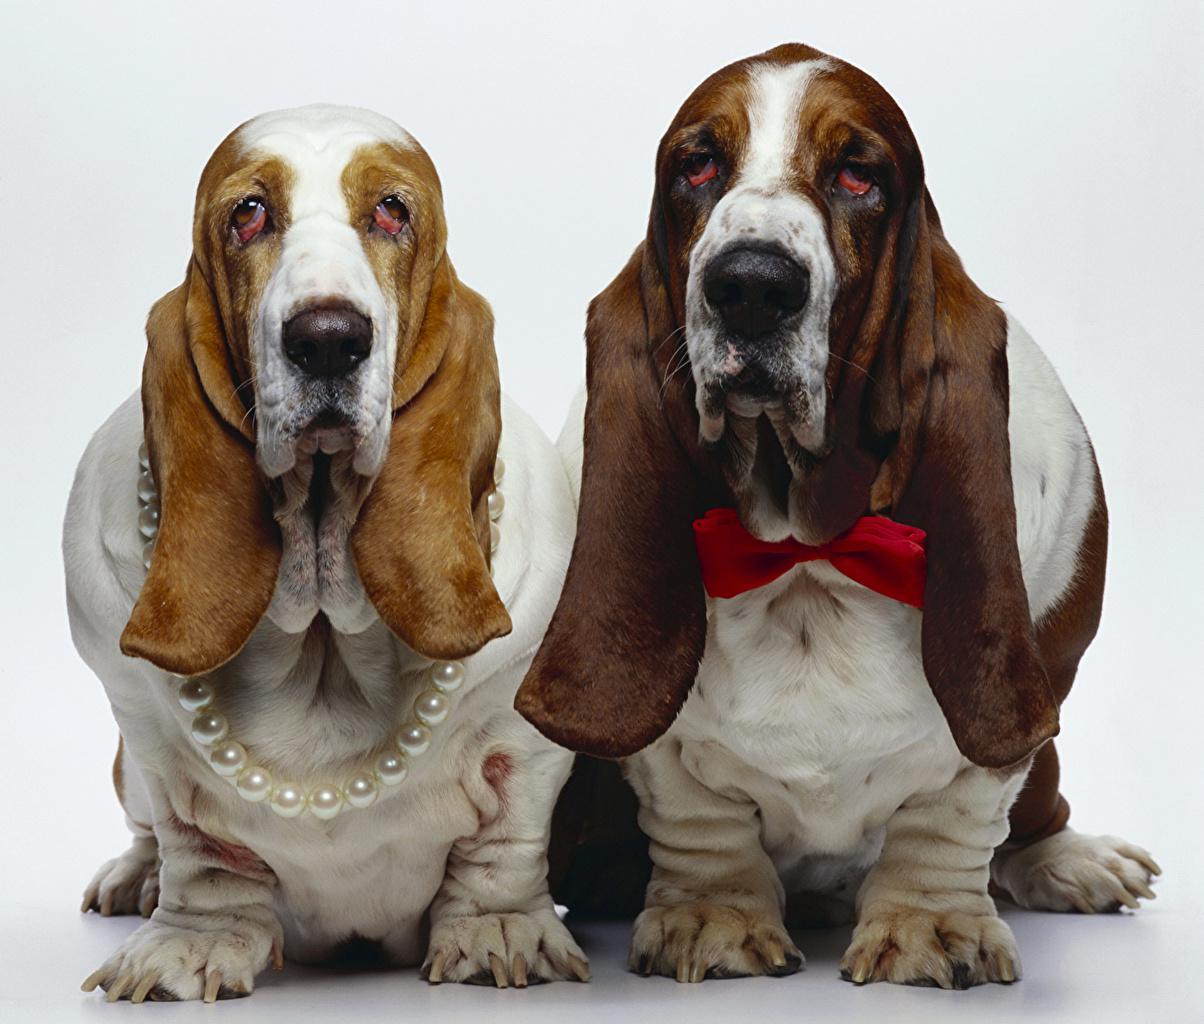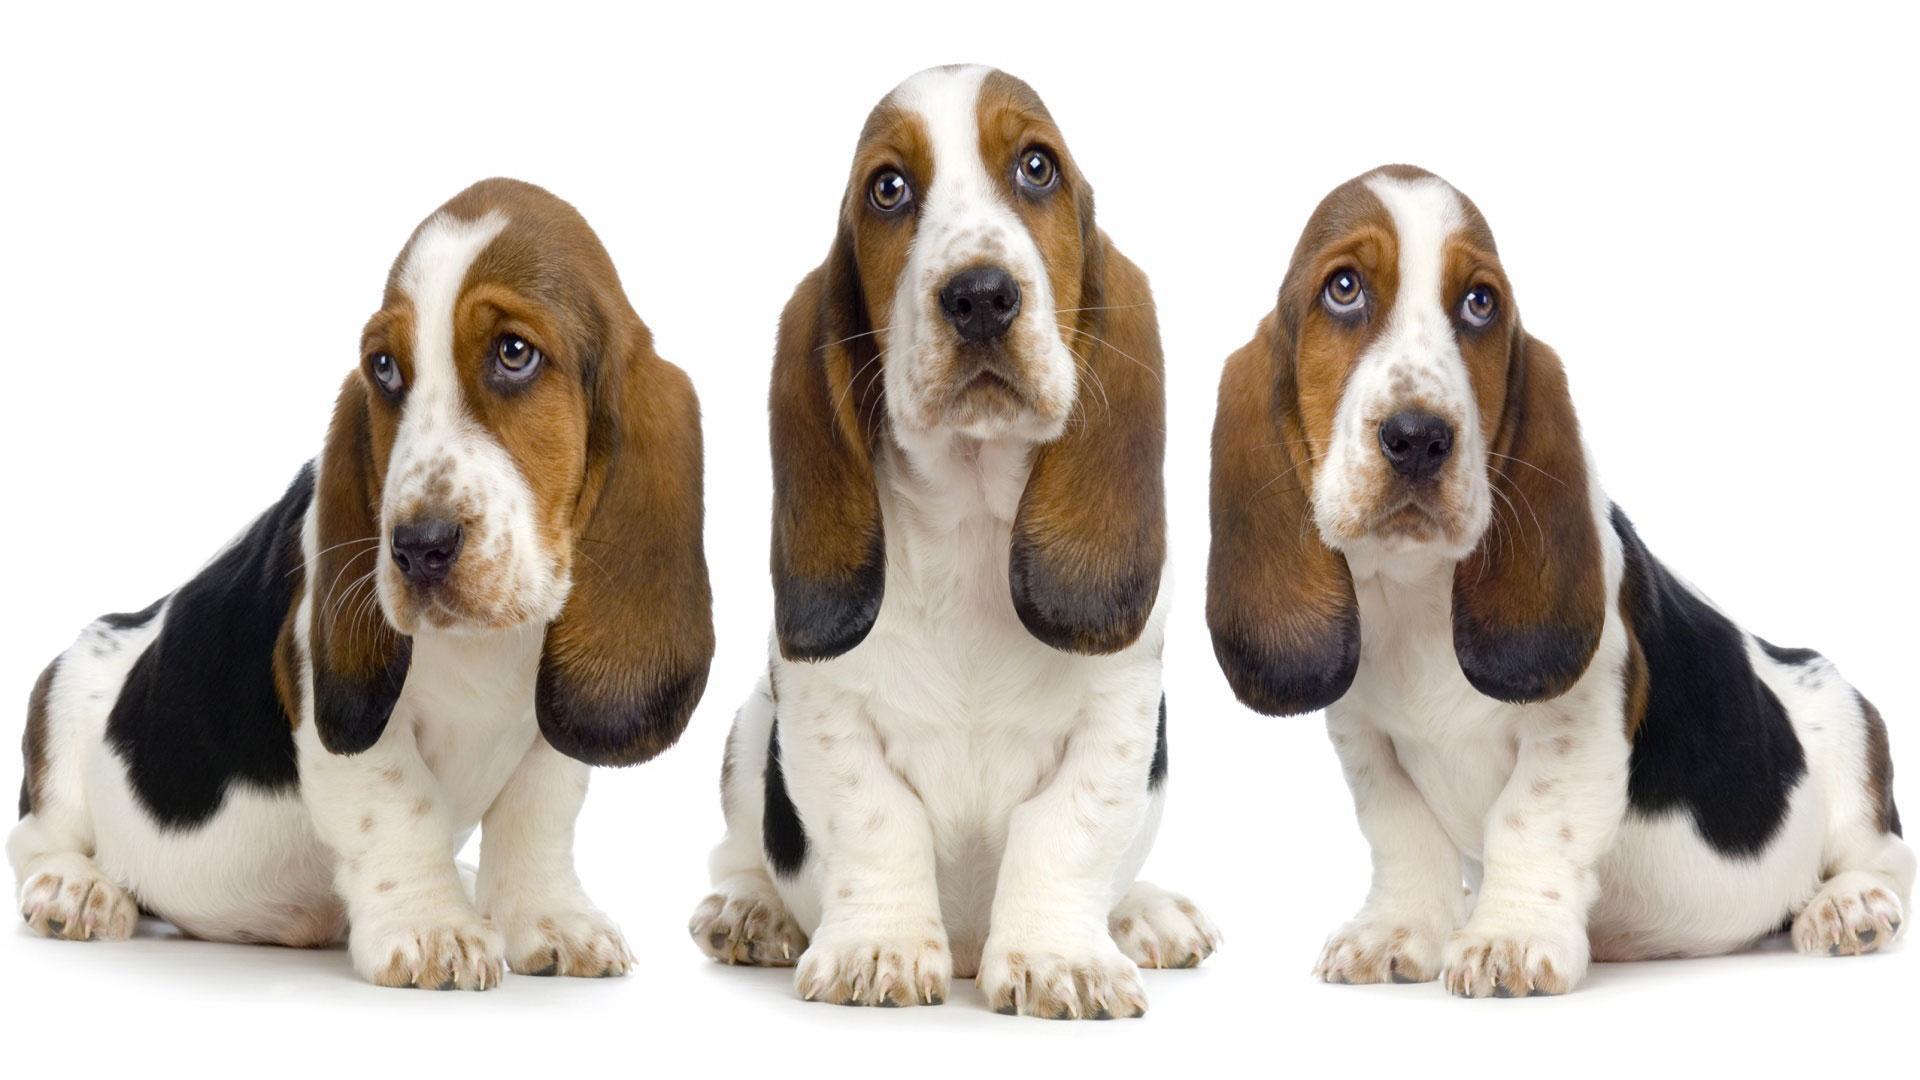The first image is the image on the left, the second image is the image on the right. For the images shown, is this caption "An image shows a long-eared basset hound posed next to another type of pet." true? Answer yes or no. No. 